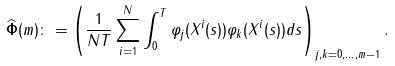Convert formula to latex. <formula><loc_0><loc_0><loc_500><loc_500>\widehat { \mathbf \Phi } ( m ) \colon = \left ( \frac { 1 } { N T } \sum _ { i = 1 } ^ { N } \int _ { 0 } ^ { T } \varphi _ { j } ( X ^ { i } ( s ) ) \varphi _ { k } ( X ^ { i } ( s ) ) d s \right ) _ { j , k = 0 , \dots , m - 1 } .</formula> 